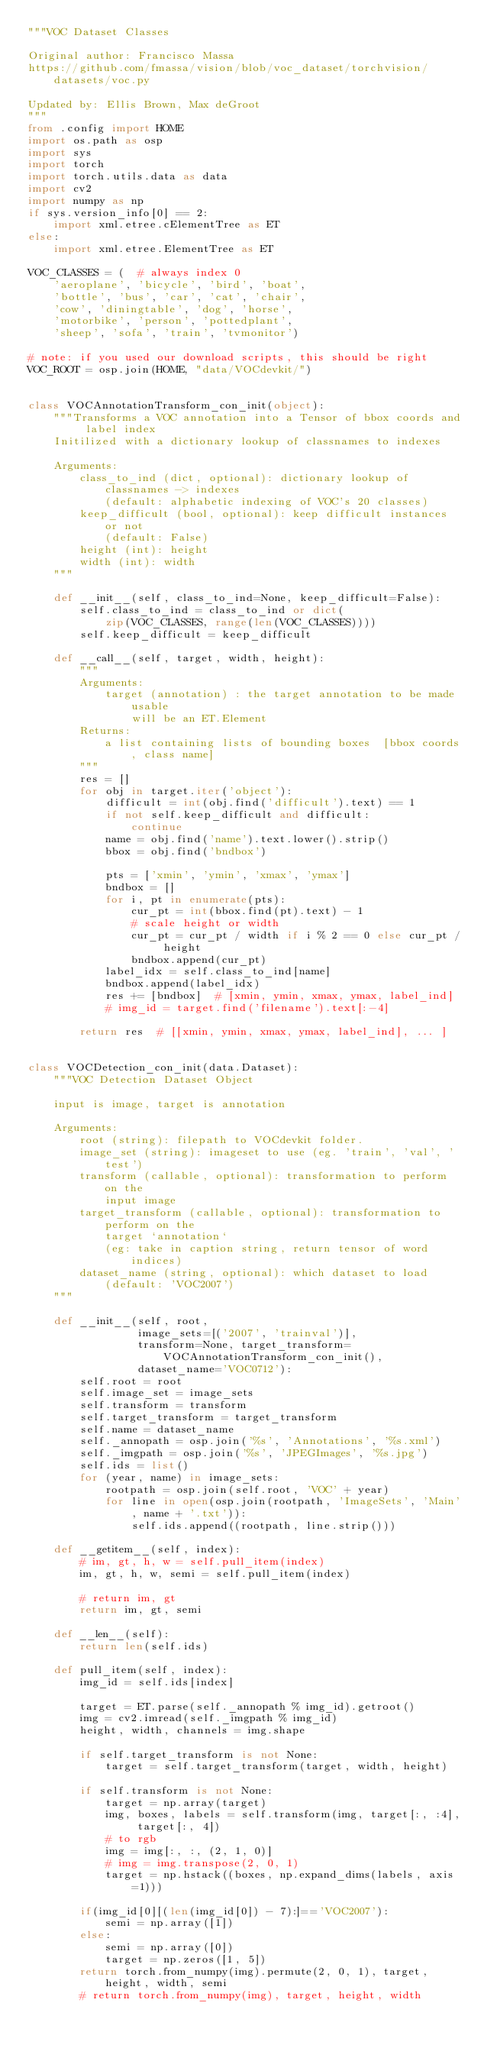Convert code to text. <code><loc_0><loc_0><loc_500><loc_500><_Python_>"""VOC Dataset Classes

Original author: Francisco Massa
https://github.com/fmassa/vision/blob/voc_dataset/torchvision/datasets/voc.py

Updated by: Ellis Brown, Max deGroot
"""
from .config import HOME
import os.path as osp
import sys
import torch
import torch.utils.data as data
import cv2
import numpy as np
if sys.version_info[0] == 2:
    import xml.etree.cElementTree as ET
else:
    import xml.etree.ElementTree as ET

VOC_CLASSES = (  # always index 0
    'aeroplane', 'bicycle', 'bird', 'boat',
    'bottle', 'bus', 'car', 'cat', 'chair',
    'cow', 'diningtable', 'dog', 'horse',
    'motorbike', 'person', 'pottedplant',
    'sheep', 'sofa', 'train', 'tvmonitor')

# note: if you used our download scripts, this should be right
VOC_ROOT = osp.join(HOME, "data/VOCdevkit/")


class VOCAnnotationTransform_con_init(object):
    """Transforms a VOC annotation into a Tensor of bbox coords and label index
    Initilized with a dictionary lookup of classnames to indexes

    Arguments:
        class_to_ind (dict, optional): dictionary lookup of classnames -> indexes
            (default: alphabetic indexing of VOC's 20 classes)
        keep_difficult (bool, optional): keep difficult instances or not
            (default: False)
        height (int): height
        width (int): width
    """

    def __init__(self, class_to_ind=None, keep_difficult=False):
        self.class_to_ind = class_to_ind or dict(
            zip(VOC_CLASSES, range(len(VOC_CLASSES))))
        self.keep_difficult = keep_difficult

    def __call__(self, target, width, height):
        """
        Arguments:
            target (annotation) : the target annotation to be made usable
                will be an ET.Element
        Returns:
            a list containing lists of bounding boxes  [bbox coords, class name]
        """
        res = []
        for obj in target.iter('object'):
            difficult = int(obj.find('difficult').text) == 1
            if not self.keep_difficult and difficult:
                continue
            name = obj.find('name').text.lower().strip()
            bbox = obj.find('bndbox')

            pts = ['xmin', 'ymin', 'xmax', 'ymax']
            bndbox = []
            for i, pt in enumerate(pts):
                cur_pt = int(bbox.find(pt).text) - 1
                # scale height or width
                cur_pt = cur_pt / width if i % 2 == 0 else cur_pt / height
                bndbox.append(cur_pt)
            label_idx = self.class_to_ind[name]
            bndbox.append(label_idx)
            res += [bndbox]  # [xmin, ymin, xmax, ymax, label_ind]
            # img_id = target.find('filename').text[:-4]

        return res  # [[xmin, ymin, xmax, ymax, label_ind], ... ]


class VOCDetection_con_init(data.Dataset):
    """VOC Detection Dataset Object

    input is image, target is annotation

    Arguments:
        root (string): filepath to VOCdevkit folder.
        image_set (string): imageset to use (eg. 'train', 'val', 'test')
        transform (callable, optional): transformation to perform on the
            input image
        target_transform (callable, optional): transformation to perform on the
            target `annotation`
            (eg: take in caption string, return tensor of word indices)
        dataset_name (string, optional): which dataset to load
            (default: 'VOC2007')
    """

    def __init__(self, root,
                 image_sets=[('2007', 'trainval')],
                 transform=None, target_transform=VOCAnnotationTransform_con_init(),
                 dataset_name='VOC0712'):
        self.root = root
        self.image_set = image_sets
        self.transform = transform
        self.target_transform = target_transform
        self.name = dataset_name
        self._annopath = osp.join('%s', 'Annotations', '%s.xml')
        self._imgpath = osp.join('%s', 'JPEGImages', '%s.jpg')
        self.ids = list()
        for (year, name) in image_sets:
            rootpath = osp.join(self.root, 'VOC' + year)
            for line in open(osp.join(rootpath, 'ImageSets', 'Main', name + '.txt')):
                self.ids.append((rootpath, line.strip()))

    def __getitem__(self, index):
        # im, gt, h, w = self.pull_item(index)
        im, gt, h, w, semi = self.pull_item(index)

        # return im, gt
        return im, gt, semi

    def __len__(self):
        return len(self.ids)

    def pull_item(self, index):
        img_id = self.ids[index]

        target = ET.parse(self._annopath % img_id).getroot()
        img = cv2.imread(self._imgpath % img_id)
        height, width, channels = img.shape

        if self.target_transform is not None:
            target = self.target_transform(target, width, height)

        if self.transform is not None:
            target = np.array(target)
            img, boxes, labels = self.transform(img, target[:, :4], target[:, 4])
            # to rgb
            img = img[:, :, (2, 1, 0)]
            # img = img.transpose(2, 0, 1)
            target = np.hstack((boxes, np.expand_dims(labels, axis=1)))

        if(img_id[0][(len(img_id[0]) - 7):]=='VOC2007'):
            semi = np.array([1])
        else:
            semi = np.array([0])
            target = np.zeros([1, 5])
        return torch.from_numpy(img).permute(2, 0, 1), target, height, width, semi
        # return torch.from_numpy(img), target, height, width
</code> 